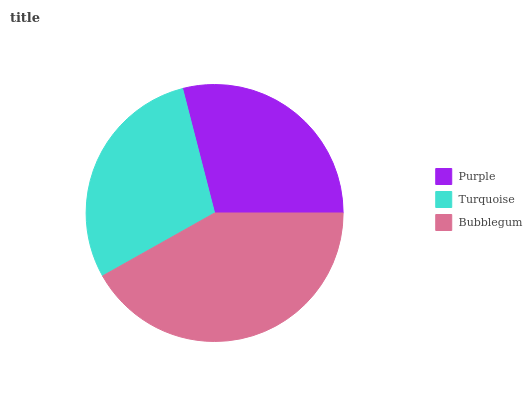Is Purple the minimum?
Answer yes or no. Yes. Is Bubblegum the maximum?
Answer yes or no. Yes. Is Turquoise the minimum?
Answer yes or no. No. Is Turquoise the maximum?
Answer yes or no. No. Is Turquoise greater than Purple?
Answer yes or no. Yes. Is Purple less than Turquoise?
Answer yes or no. Yes. Is Purple greater than Turquoise?
Answer yes or no. No. Is Turquoise less than Purple?
Answer yes or no. No. Is Turquoise the high median?
Answer yes or no. Yes. Is Turquoise the low median?
Answer yes or no. Yes. Is Bubblegum the high median?
Answer yes or no. No. Is Bubblegum the low median?
Answer yes or no. No. 